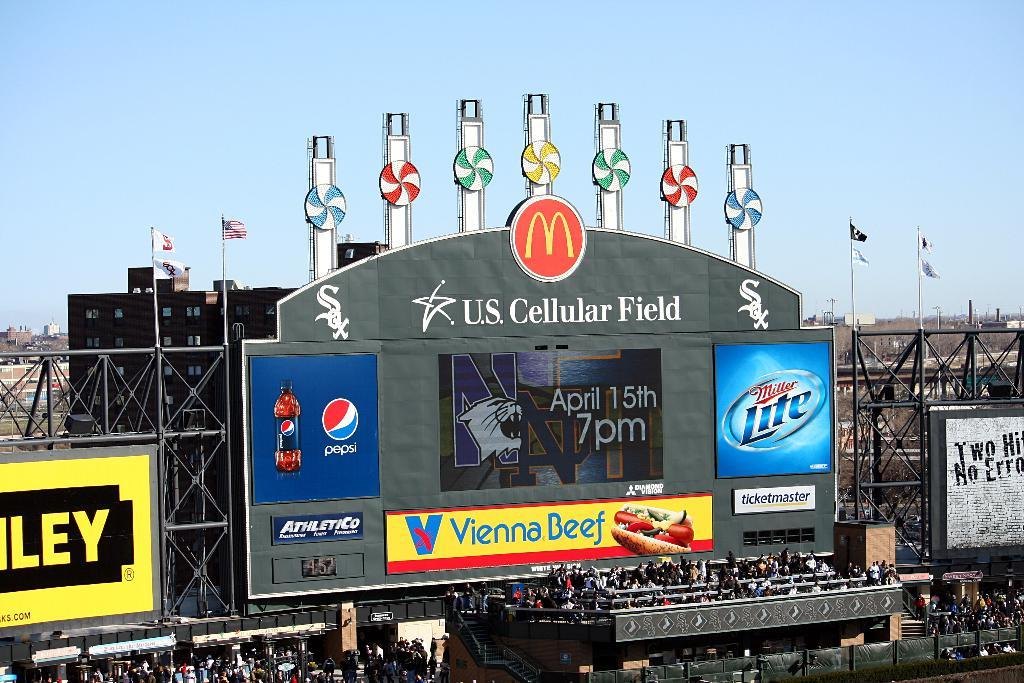<image>
Provide a brief description of the given image. View of a stadium with sponsors such as Pepsi, Miller Lite, McDonald, Vienna Beef etc. 